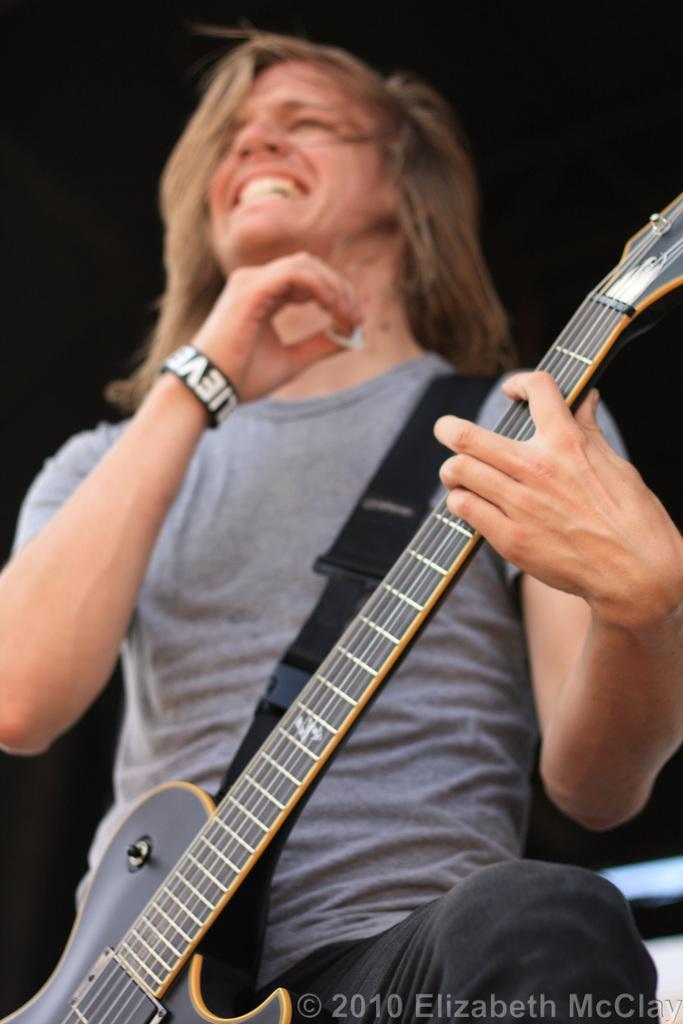Please provide a concise description of this image. In this picture we can see man holding guitar in his hand with strap and he is smiling and in background it is dark. 